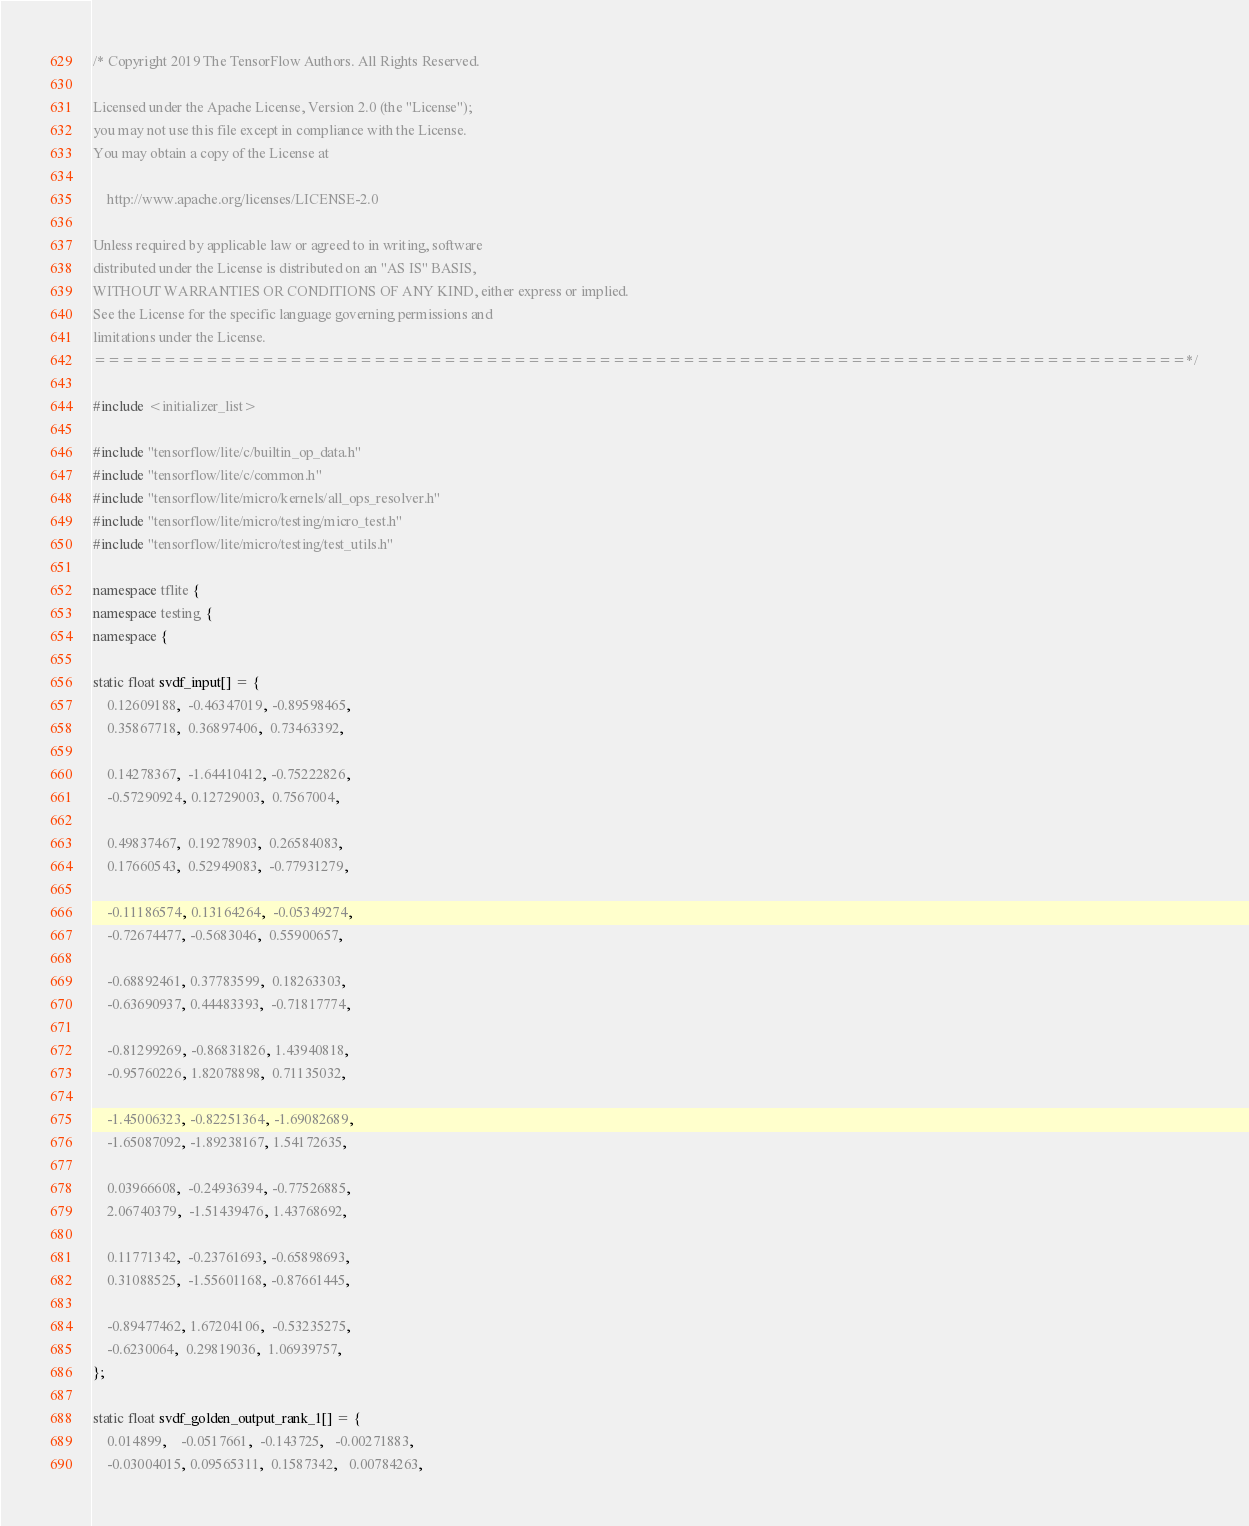Convert code to text. <code><loc_0><loc_0><loc_500><loc_500><_C++_>/* Copyright 2019 The TensorFlow Authors. All Rights Reserved.

Licensed under the Apache License, Version 2.0 (the "License");
you may not use this file except in compliance with the License.
You may obtain a copy of the License at

    http://www.apache.org/licenses/LICENSE-2.0

Unless required by applicable law or agreed to in writing, software
distributed under the License is distributed on an "AS IS" BASIS,
WITHOUT WARRANTIES OR CONDITIONS OF ANY KIND, either express or implied.
See the License for the specific language governing permissions and
limitations under the License.
==============================================================================*/

#include <initializer_list>

#include "tensorflow/lite/c/builtin_op_data.h"
#include "tensorflow/lite/c/common.h"
#include "tensorflow/lite/micro/kernels/all_ops_resolver.h"
#include "tensorflow/lite/micro/testing/micro_test.h"
#include "tensorflow/lite/micro/testing/test_utils.h"

namespace tflite {
namespace testing {
namespace {

static float svdf_input[] = {
    0.12609188,  -0.46347019, -0.89598465,
    0.35867718,  0.36897406,  0.73463392,

    0.14278367,  -1.64410412, -0.75222826,
    -0.57290924, 0.12729003,  0.7567004,

    0.49837467,  0.19278903,  0.26584083,
    0.17660543,  0.52949083,  -0.77931279,

    -0.11186574, 0.13164264,  -0.05349274,
    -0.72674477, -0.5683046,  0.55900657,

    -0.68892461, 0.37783599,  0.18263303,
    -0.63690937, 0.44483393,  -0.71817774,

    -0.81299269, -0.86831826, 1.43940818,
    -0.95760226, 1.82078898,  0.71135032,

    -1.45006323, -0.82251364, -1.69082689,
    -1.65087092, -1.89238167, 1.54172635,

    0.03966608,  -0.24936394, -0.77526885,
    2.06740379,  -1.51439476, 1.43768692,

    0.11771342,  -0.23761693, -0.65898693,
    0.31088525,  -1.55601168, -0.87661445,

    -0.89477462, 1.67204106,  -0.53235275,
    -0.6230064,  0.29819036,  1.06939757,
};

static float svdf_golden_output_rank_1[] = {
    0.014899,    -0.0517661,  -0.143725,   -0.00271883,
    -0.03004015, 0.09565311,  0.1587342,   0.00784263,
</code> 